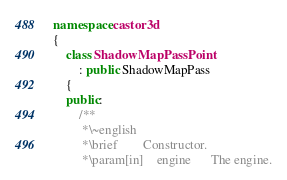<code> <loc_0><loc_0><loc_500><loc_500><_C++_>namespace castor3d
{
	class ShadowMapPassPoint
		: public ShadowMapPass
	{
	public:
		/**
		 *\~english
		 *\brief		Constructor.
		 *\param[in]	engine		The engine.</code> 